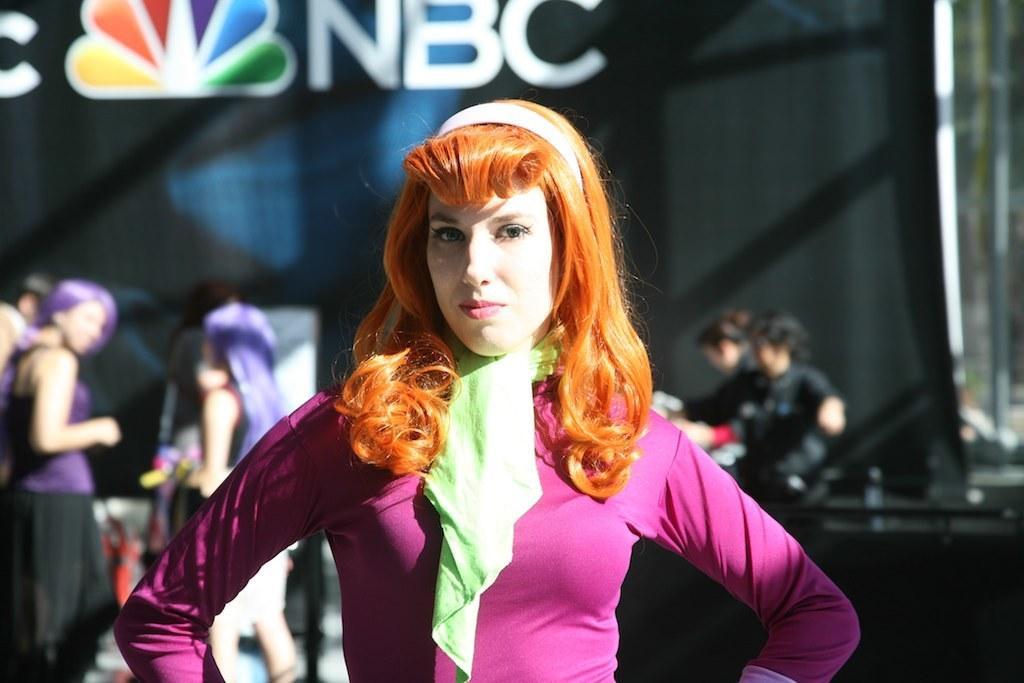Please provide a concise description of this image. In the center of the image we can see one woman is standing and she is in a different costume. In the background, we can see a few people and a few other objects. 